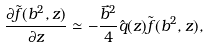<formula> <loc_0><loc_0><loc_500><loc_500>\frac { \partial \tilde { f } ( b ^ { 2 } , z ) } { \partial z } \simeq - \frac { \vec { b } ^ { 2 } } { 4 } \hat { q } ( z ) \tilde { f } ( b ^ { 2 } , z ) ,</formula> 